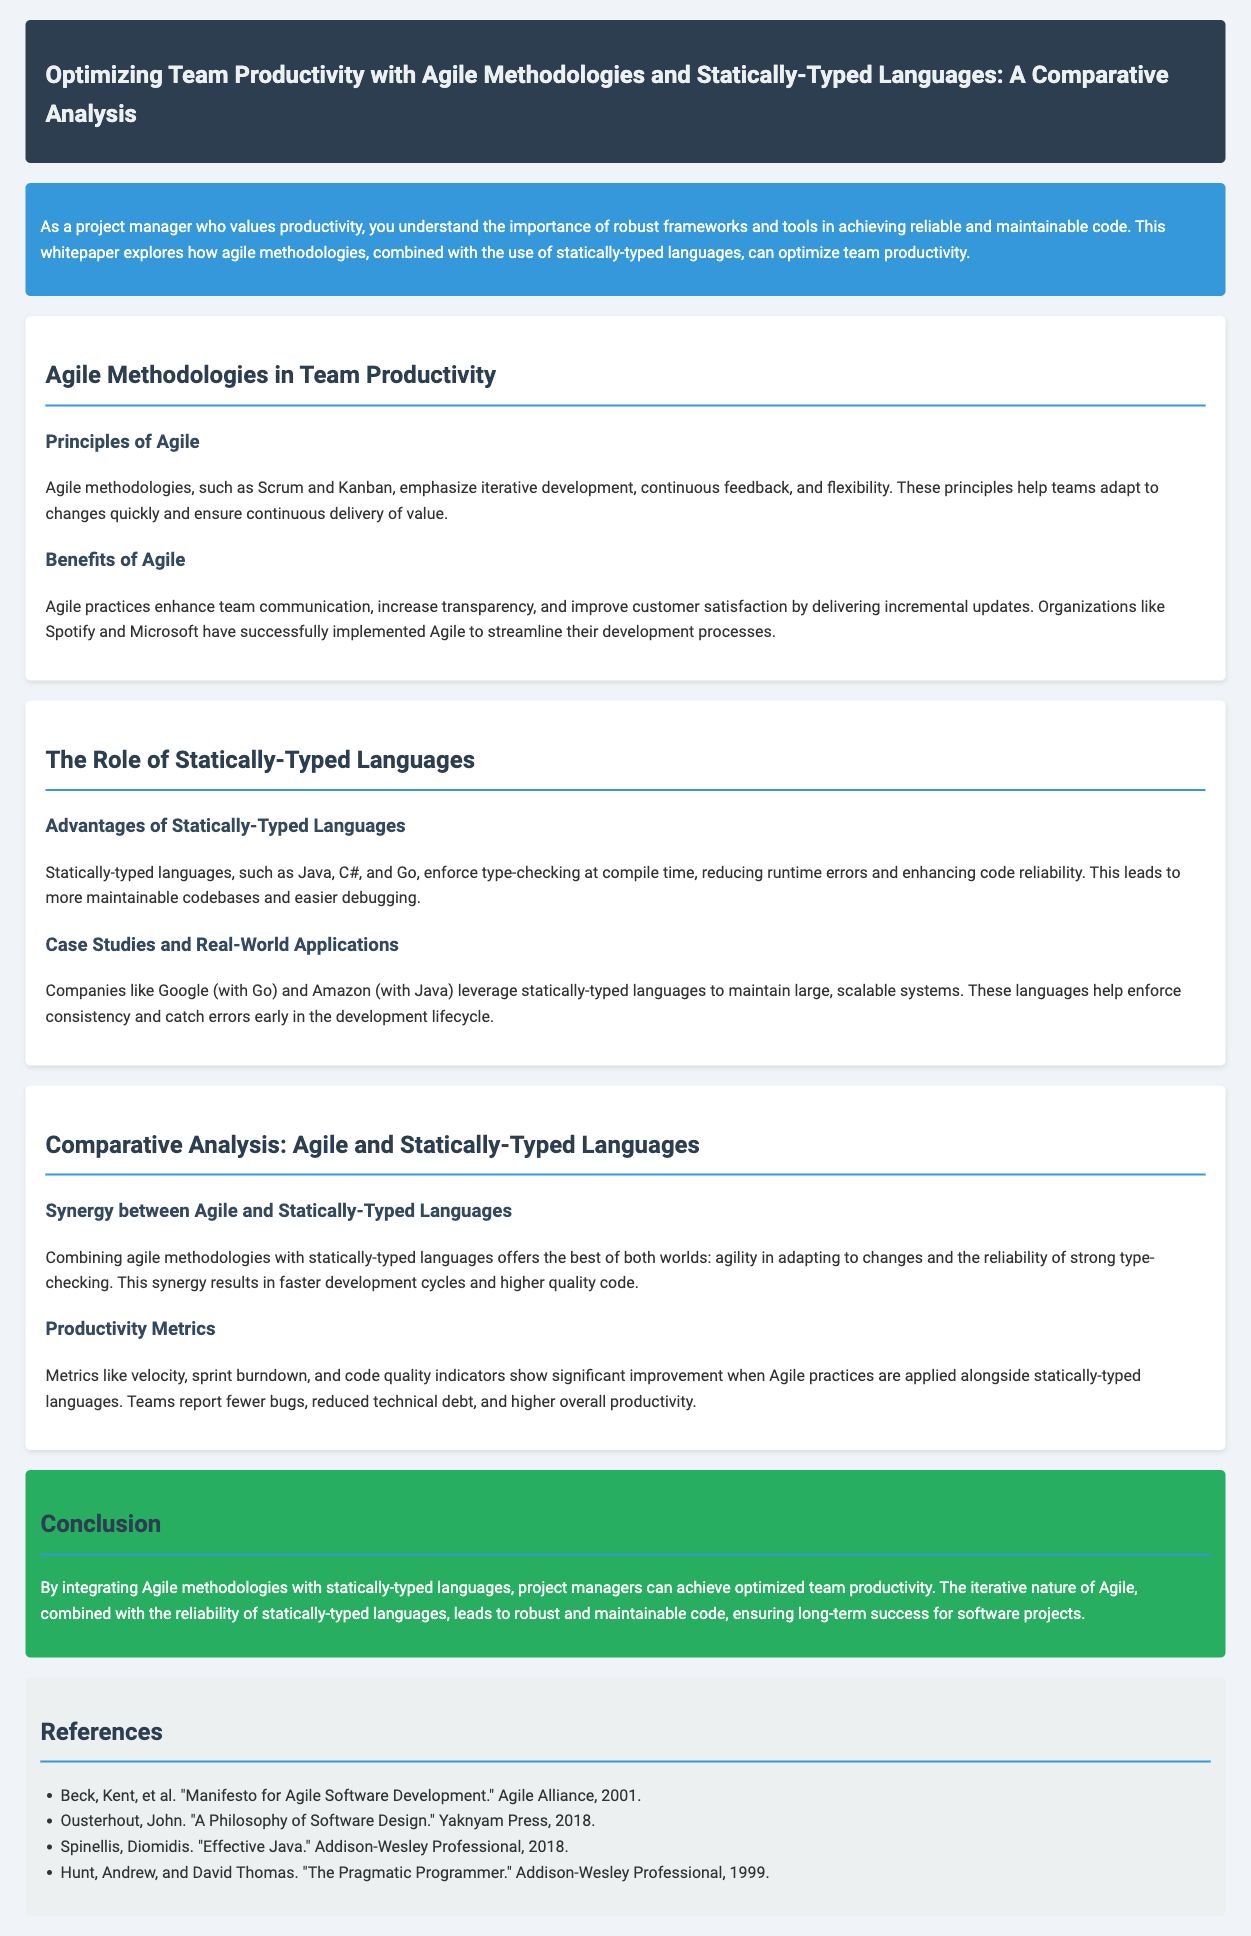What are Agile methodologies focused on? Agile methodologies emphasize iterative development, continuous feedback, and flexibility, which help teams adapt to changes quickly.
Answer: Iterative development Which statically-typed language does Google leverage? Google leverages Go, a statically-typed language, to maintain large and scalable systems.
Answer: Go What is one benefit of Agile practices mentioned in the document? Agile practices enhance team communication, increase transparency, and improve customer satisfaction by delivering incremental updates.
Answer: Improved customer satisfaction What do metrics like velocity and sprint burndown indicate? Metrics like velocity, sprint burndown, and code quality indicators show significant improvement when Agile practices are applied alongside statically-typed languages.
Answer: Significant improvement What is the main conclusion of the whitepaper? The whitepaper concludes that integrating Agile methodologies with statically-typed languages leads to robust and maintainable code, ensuring long-term success for software projects.
Answer: Optimized team productivity 